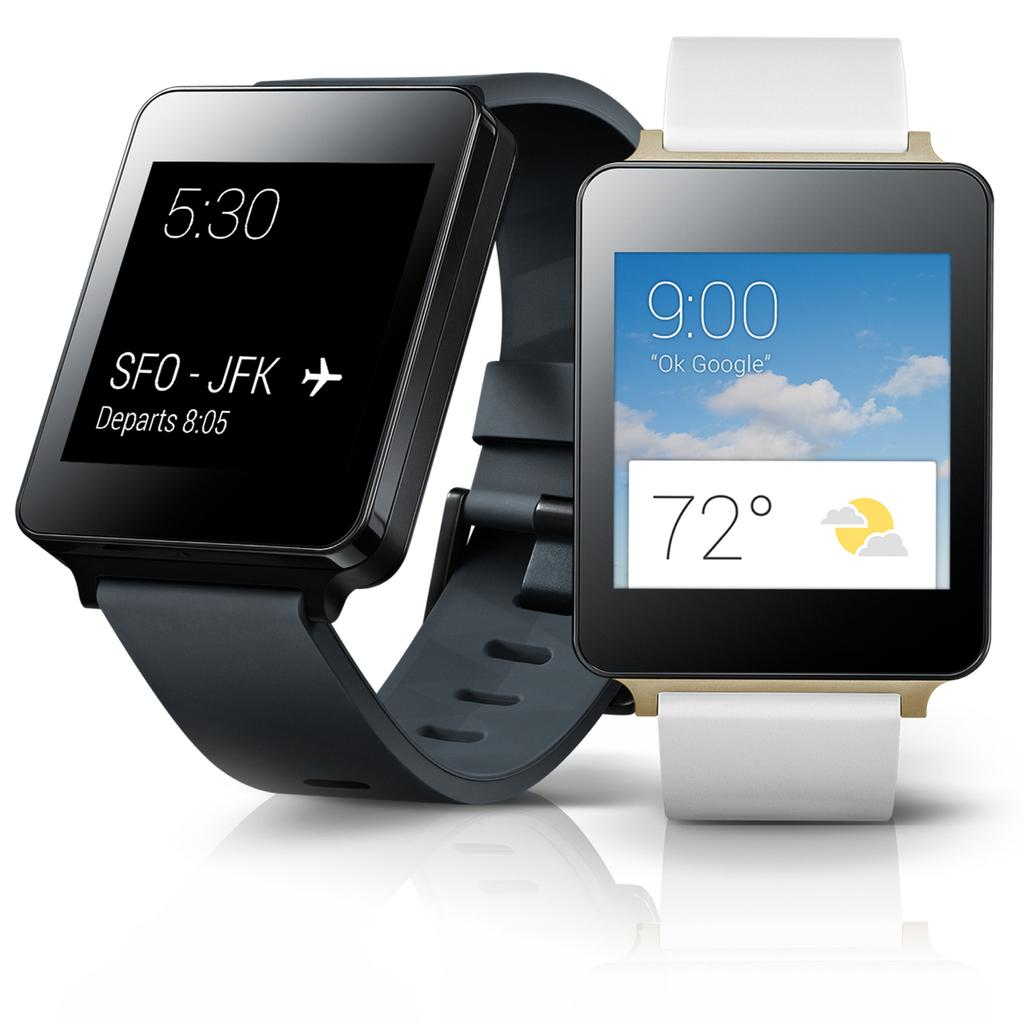<image>
Write a terse but informative summary of the picture. A black smart watch tells its owner that their flight departs at 8:05. 